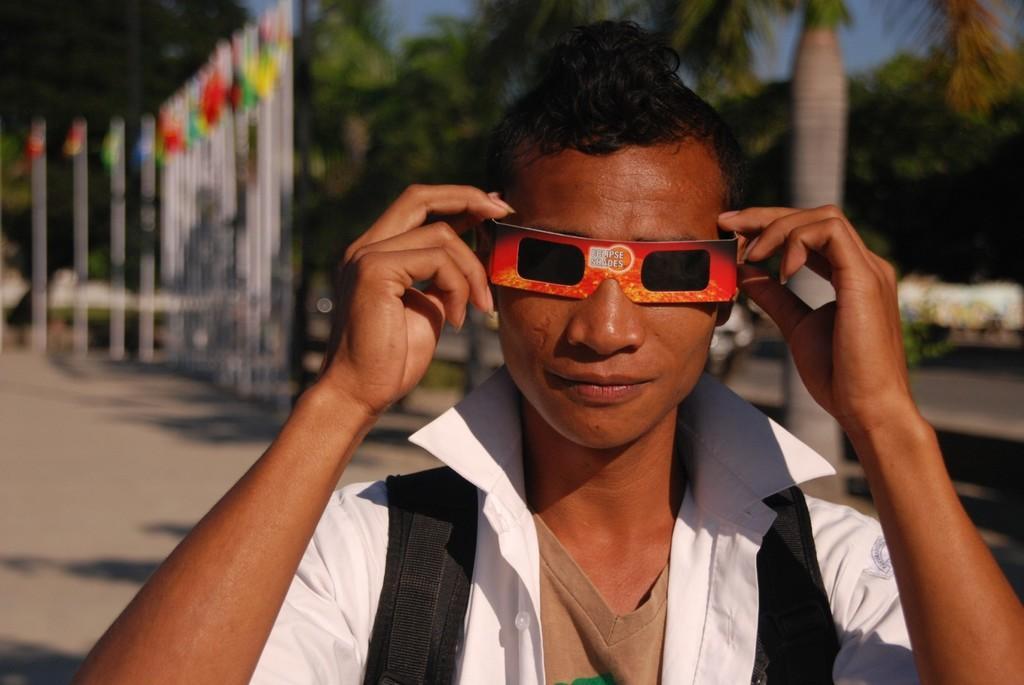Describe this image in one or two sentences. In this image I can see the person and the person is wearing white color shirt and glasses, background I can see few multicolor flags, trees in green color and the sky is in blue color. 